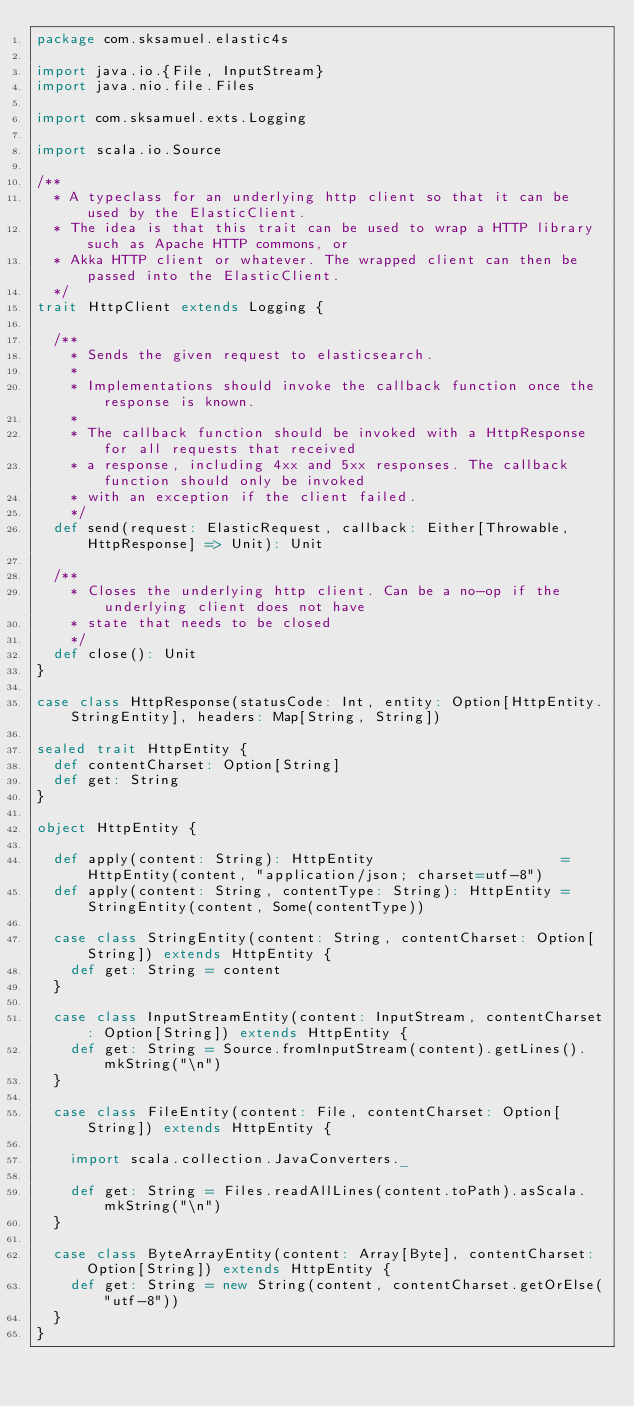<code> <loc_0><loc_0><loc_500><loc_500><_Scala_>package com.sksamuel.elastic4s

import java.io.{File, InputStream}
import java.nio.file.Files

import com.sksamuel.exts.Logging

import scala.io.Source

/**
  * A typeclass for an underlying http client so that it can be used by the ElasticClient.
  * The idea is that this trait can be used to wrap a HTTP library such as Apache HTTP commons, or
  * Akka HTTP client or whatever. The wrapped client can then be passed into the ElasticClient.
  */
trait HttpClient extends Logging {

  /**
    * Sends the given request to elasticsearch.
    *
    * Implementations should invoke the callback function once the response is known.
    *
    * The callback function should be invoked with a HttpResponse for all requests that received
    * a response, including 4xx and 5xx responses. The callback function should only be invoked
    * with an exception if the client failed.
    */
  def send(request: ElasticRequest, callback: Either[Throwable, HttpResponse] => Unit): Unit

  /**
    * Closes the underlying http client. Can be a no-op if the underlying client does not have
    * state that needs to be closed
    */
  def close(): Unit
}

case class HttpResponse(statusCode: Int, entity: Option[HttpEntity.StringEntity], headers: Map[String, String])

sealed trait HttpEntity {
  def contentCharset: Option[String]
  def get: String
}

object HttpEntity {

  def apply(content: String): HttpEntity                      = HttpEntity(content, "application/json; charset=utf-8")
  def apply(content: String, contentType: String): HttpEntity = StringEntity(content, Some(contentType))

  case class StringEntity(content: String, contentCharset: Option[String]) extends HttpEntity {
    def get: String = content
  }

  case class InputStreamEntity(content: InputStream, contentCharset: Option[String]) extends HttpEntity {
    def get: String = Source.fromInputStream(content).getLines().mkString("\n")
  }

  case class FileEntity(content: File, contentCharset: Option[String]) extends HttpEntity {

    import scala.collection.JavaConverters._

    def get: String = Files.readAllLines(content.toPath).asScala.mkString("\n")
  }

  case class ByteArrayEntity(content: Array[Byte], contentCharset: Option[String]) extends HttpEntity {
    def get: String = new String(content, contentCharset.getOrElse("utf-8"))
  }
}
</code> 